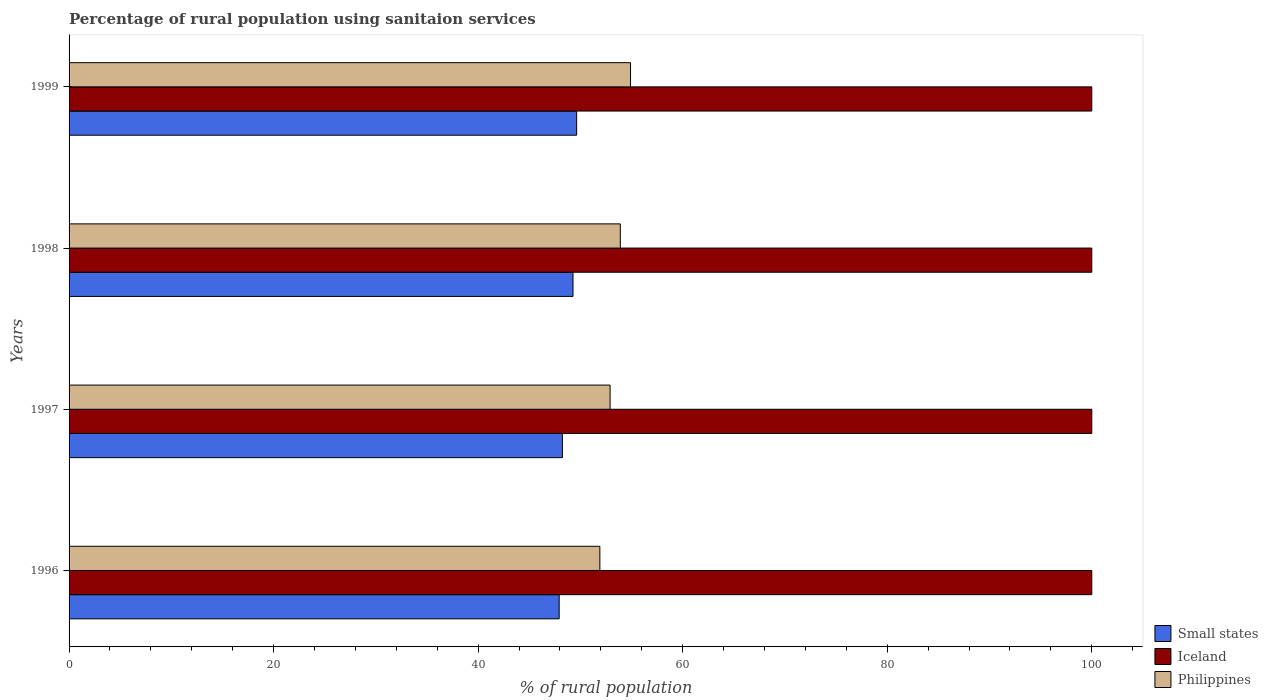How many different coloured bars are there?
Provide a short and direct response. 3. How many groups of bars are there?
Make the answer very short. 4. Are the number of bars per tick equal to the number of legend labels?
Ensure brevity in your answer.  Yes. Are the number of bars on each tick of the Y-axis equal?
Your answer should be compact. Yes. How many bars are there on the 4th tick from the top?
Ensure brevity in your answer.  3. What is the label of the 3rd group of bars from the top?
Your answer should be very brief. 1997. In how many cases, is the number of bars for a given year not equal to the number of legend labels?
Your answer should be compact. 0. What is the percentage of rural population using sanitaion services in Iceland in 1999?
Your answer should be very brief. 100. Across all years, what is the maximum percentage of rural population using sanitaion services in Small states?
Ensure brevity in your answer.  49.63. Across all years, what is the minimum percentage of rural population using sanitaion services in Small states?
Offer a terse response. 47.92. In which year was the percentage of rural population using sanitaion services in Small states maximum?
Provide a succinct answer. 1999. What is the total percentage of rural population using sanitaion services in Philippines in the graph?
Offer a very short reply. 213.6. What is the difference between the percentage of rural population using sanitaion services in Iceland in 1998 and the percentage of rural population using sanitaion services in Small states in 1997?
Your answer should be compact. 51.76. What is the average percentage of rural population using sanitaion services in Small states per year?
Make the answer very short. 48.77. In the year 1999, what is the difference between the percentage of rural population using sanitaion services in Iceland and percentage of rural population using sanitaion services in Small states?
Your answer should be compact. 50.37. In how many years, is the percentage of rural population using sanitaion services in Philippines greater than 64 %?
Provide a succinct answer. 0. What is the ratio of the percentage of rural population using sanitaion services in Small states in 1996 to that in 1998?
Provide a short and direct response. 0.97. Is the difference between the percentage of rural population using sanitaion services in Iceland in 1996 and 1999 greater than the difference between the percentage of rural population using sanitaion services in Small states in 1996 and 1999?
Keep it short and to the point. Yes. What is the difference between the highest and the second highest percentage of rural population using sanitaion services in Small states?
Ensure brevity in your answer.  0.36. What does the 3rd bar from the top in 1996 represents?
Make the answer very short. Small states. Is it the case that in every year, the sum of the percentage of rural population using sanitaion services in Small states and percentage of rural population using sanitaion services in Iceland is greater than the percentage of rural population using sanitaion services in Philippines?
Ensure brevity in your answer.  Yes. Are all the bars in the graph horizontal?
Keep it short and to the point. Yes. Are the values on the major ticks of X-axis written in scientific E-notation?
Provide a succinct answer. No. Does the graph contain grids?
Provide a short and direct response. No. How are the legend labels stacked?
Keep it short and to the point. Vertical. What is the title of the graph?
Provide a short and direct response. Percentage of rural population using sanitaion services. What is the label or title of the X-axis?
Keep it short and to the point. % of rural population. What is the % of rural population in Small states in 1996?
Offer a very short reply. 47.92. What is the % of rural population in Philippines in 1996?
Offer a very short reply. 51.9. What is the % of rural population in Small states in 1997?
Make the answer very short. 48.24. What is the % of rural population in Philippines in 1997?
Your answer should be very brief. 52.9. What is the % of rural population in Small states in 1998?
Provide a succinct answer. 49.27. What is the % of rural population of Iceland in 1998?
Offer a very short reply. 100. What is the % of rural population of Philippines in 1998?
Ensure brevity in your answer.  53.9. What is the % of rural population in Small states in 1999?
Your answer should be compact. 49.63. What is the % of rural population in Iceland in 1999?
Your answer should be very brief. 100. What is the % of rural population in Philippines in 1999?
Give a very brief answer. 54.9. Across all years, what is the maximum % of rural population of Small states?
Provide a short and direct response. 49.63. Across all years, what is the maximum % of rural population of Philippines?
Your answer should be very brief. 54.9. Across all years, what is the minimum % of rural population of Small states?
Offer a terse response. 47.92. Across all years, what is the minimum % of rural population in Iceland?
Ensure brevity in your answer.  100. Across all years, what is the minimum % of rural population in Philippines?
Offer a very short reply. 51.9. What is the total % of rural population in Small states in the graph?
Your answer should be compact. 195.07. What is the total % of rural population in Iceland in the graph?
Make the answer very short. 400. What is the total % of rural population of Philippines in the graph?
Make the answer very short. 213.6. What is the difference between the % of rural population in Small states in 1996 and that in 1997?
Offer a very short reply. -0.32. What is the difference between the % of rural population in Iceland in 1996 and that in 1997?
Offer a very short reply. 0. What is the difference between the % of rural population of Small states in 1996 and that in 1998?
Keep it short and to the point. -1.35. What is the difference between the % of rural population in Philippines in 1996 and that in 1998?
Offer a very short reply. -2. What is the difference between the % of rural population of Small states in 1996 and that in 1999?
Provide a short and direct response. -1.71. What is the difference between the % of rural population of Iceland in 1996 and that in 1999?
Your answer should be compact. 0. What is the difference between the % of rural population of Philippines in 1996 and that in 1999?
Your response must be concise. -3. What is the difference between the % of rural population in Small states in 1997 and that in 1998?
Offer a terse response. -1.04. What is the difference between the % of rural population in Iceland in 1997 and that in 1998?
Your response must be concise. 0. What is the difference between the % of rural population in Small states in 1997 and that in 1999?
Ensure brevity in your answer.  -1.39. What is the difference between the % of rural population in Philippines in 1997 and that in 1999?
Make the answer very short. -2. What is the difference between the % of rural population of Small states in 1998 and that in 1999?
Keep it short and to the point. -0.36. What is the difference between the % of rural population of Philippines in 1998 and that in 1999?
Give a very brief answer. -1. What is the difference between the % of rural population in Small states in 1996 and the % of rural population in Iceland in 1997?
Your answer should be compact. -52.08. What is the difference between the % of rural population in Small states in 1996 and the % of rural population in Philippines in 1997?
Your response must be concise. -4.98. What is the difference between the % of rural population of Iceland in 1996 and the % of rural population of Philippines in 1997?
Your response must be concise. 47.1. What is the difference between the % of rural population in Small states in 1996 and the % of rural population in Iceland in 1998?
Your answer should be compact. -52.08. What is the difference between the % of rural population of Small states in 1996 and the % of rural population of Philippines in 1998?
Provide a succinct answer. -5.98. What is the difference between the % of rural population in Iceland in 1996 and the % of rural population in Philippines in 1998?
Your answer should be very brief. 46.1. What is the difference between the % of rural population in Small states in 1996 and the % of rural population in Iceland in 1999?
Your response must be concise. -52.08. What is the difference between the % of rural population in Small states in 1996 and the % of rural population in Philippines in 1999?
Ensure brevity in your answer.  -6.98. What is the difference between the % of rural population of Iceland in 1996 and the % of rural population of Philippines in 1999?
Offer a very short reply. 45.1. What is the difference between the % of rural population of Small states in 1997 and the % of rural population of Iceland in 1998?
Your response must be concise. -51.76. What is the difference between the % of rural population in Small states in 1997 and the % of rural population in Philippines in 1998?
Offer a terse response. -5.66. What is the difference between the % of rural population of Iceland in 1997 and the % of rural population of Philippines in 1998?
Offer a terse response. 46.1. What is the difference between the % of rural population of Small states in 1997 and the % of rural population of Iceland in 1999?
Offer a very short reply. -51.76. What is the difference between the % of rural population in Small states in 1997 and the % of rural population in Philippines in 1999?
Provide a short and direct response. -6.66. What is the difference between the % of rural population in Iceland in 1997 and the % of rural population in Philippines in 1999?
Offer a very short reply. 45.1. What is the difference between the % of rural population in Small states in 1998 and the % of rural population in Iceland in 1999?
Provide a short and direct response. -50.73. What is the difference between the % of rural population in Small states in 1998 and the % of rural population in Philippines in 1999?
Provide a short and direct response. -5.63. What is the difference between the % of rural population in Iceland in 1998 and the % of rural population in Philippines in 1999?
Provide a succinct answer. 45.1. What is the average % of rural population of Small states per year?
Offer a terse response. 48.77. What is the average % of rural population in Philippines per year?
Your answer should be very brief. 53.4. In the year 1996, what is the difference between the % of rural population in Small states and % of rural population in Iceland?
Provide a succinct answer. -52.08. In the year 1996, what is the difference between the % of rural population in Small states and % of rural population in Philippines?
Ensure brevity in your answer.  -3.98. In the year 1996, what is the difference between the % of rural population in Iceland and % of rural population in Philippines?
Your answer should be very brief. 48.1. In the year 1997, what is the difference between the % of rural population of Small states and % of rural population of Iceland?
Ensure brevity in your answer.  -51.76. In the year 1997, what is the difference between the % of rural population of Small states and % of rural population of Philippines?
Your response must be concise. -4.66. In the year 1997, what is the difference between the % of rural population in Iceland and % of rural population in Philippines?
Offer a terse response. 47.1. In the year 1998, what is the difference between the % of rural population of Small states and % of rural population of Iceland?
Your answer should be very brief. -50.73. In the year 1998, what is the difference between the % of rural population in Small states and % of rural population in Philippines?
Your response must be concise. -4.63. In the year 1998, what is the difference between the % of rural population in Iceland and % of rural population in Philippines?
Provide a short and direct response. 46.1. In the year 1999, what is the difference between the % of rural population in Small states and % of rural population in Iceland?
Your answer should be compact. -50.37. In the year 1999, what is the difference between the % of rural population of Small states and % of rural population of Philippines?
Give a very brief answer. -5.27. In the year 1999, what is the difference between the % of rural population in Iceland and % of rural population in Philippines?
Your answer should be compact. 45.1. What is the ratio of the % of rural population in Iceland in 1996 to that in 1997?
Keep it short and to the point. 1. What is the ratio of the % of rural population of Philippines in 1996 to that in 1997?
Offer a terse response. 0.98. What is the ratio of the % of rural population of Small states in 1996 to that in 1998?
Provide a short and direct response. 0.97. What is the ratio of the % of rural population of Philippines in 1996 to that in 1998?
Your answer should be very brief. 0.96. What is the ratio of the % of rural population in Small states in 1996 to that in 1999?
Give a very brief answer. 0.97. What is the ratio of the % of rural population of Iceland in 1996 to that in 1999?
Give a very brief answer. 1. What is the ratio of the % of rural population in Philippines in 1996 to that in 1999?
Offer a very short reply. 0.95. What is the ratio of the % of rural population in Iceland in 1997 to that in 1998?
Keep it short and to the point. 1. What is the ratio of the % of rural population in Philippines in 1997 to that in 1998?
Offer a terse response. 0.98. What is the ratio of the % of rural population of Small states in 1997 to that in 1999?
Make the answer very short. 0.97. What is the ratio of the % of rural population in Philippines in 1997 to that in 1999?
Ensure brevity in your answer.  0.96. What is the ratio of the % of rural population in Small states in 1998 to that in 1999?
Keep it short and to the point. 0.99. What is the ratio of the % of rural population of Philippines in 1998 to that in 1999?
Provide a succinct answer. 0.98. What is the difference between the highest and the second highest % of rural population in Small states?
Provide a short and direct response. 0.36. What is the difference between the highest and the second highest % of rural population of Iceland?
Your answer should be compact. 0. What is the difference between the highest and the second highest % of rural population in Philippines?
Ensure brevity in your answer.  1. What is the difference between the highest and the lowest % of rural population in Small states?
Offer a very short reply. 1.71. What is the difference between the highest and the lowest % of rural population in Philippines?
Provide a succinct answer. 3. 